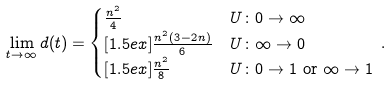<formula> <loc_0><loc_0><loc_500><loc_500>\lim _ { t \to \infty } d ( t ) & = \begin{cases} \frac { n ^ { 2 } } { 4 } & U \colon 0 \to \infty \\ [ 1 . 5 e x ] \frac { n ^ { 2 } ( 3 - 2 n ) } { 6 } & U \colon \infty \to 0 \\ [ 1 . 5 e x ] \frac { n ^ { 2 } } { 8 } & U \colon 0 \to 1 \text { or } \infty \to 1 \end{cases} \, .</formula> 